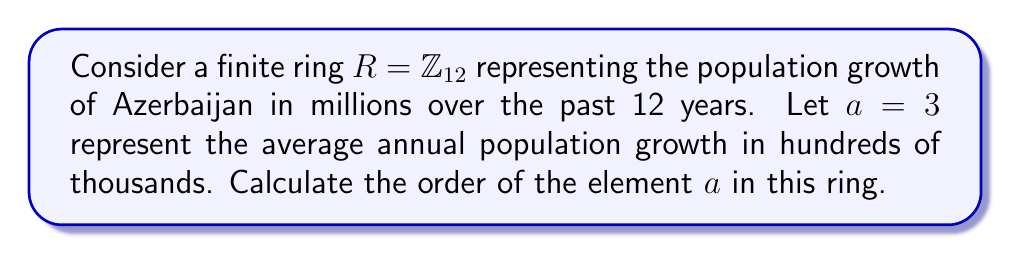Help me with this question. To solve this problem, we need to follow these steps:

1) In a ring, the order of an element $a$ is the smallest positive integer $n$ such that $na = 0$ (where $0$ is the additive identity of the ring).

2) In $\mathbb{Z}_{12}$, we need to find the smallest positive integer $n$ such that $3n \equiv 0 \pmod{12}$.

3) Let's calculate the multiples of $3$ in $\mathbb{Z}_{12}$:

   $1 \cdot 3 \equiv 3 \pmod{12}$
   $2 \cdot 3 \equiv 6 \pmod{12}$
   $3 \cdot 3 \equiv 9 \pmod{12}$
   $4 \cdot 3 \equiv 0 \pmod{12}$

4) We see that $4 \cdot 3 \equiv 0 \pmod{12}$, and this is the smallest positive integer that satisfies this condition.

5) Therefore, the order of $3$ in $\mathbb{Z}_{12}$ is 4.

In the context of Azerbaijan's population growth, this means that the effect of the average annual growth would cycle back to zero (in terms of millions) every 4 years in this simplified model.
Answer: The order of the element $a = 3$ in the ring $R = \mathbb{Z}_{12}$ is 4. 